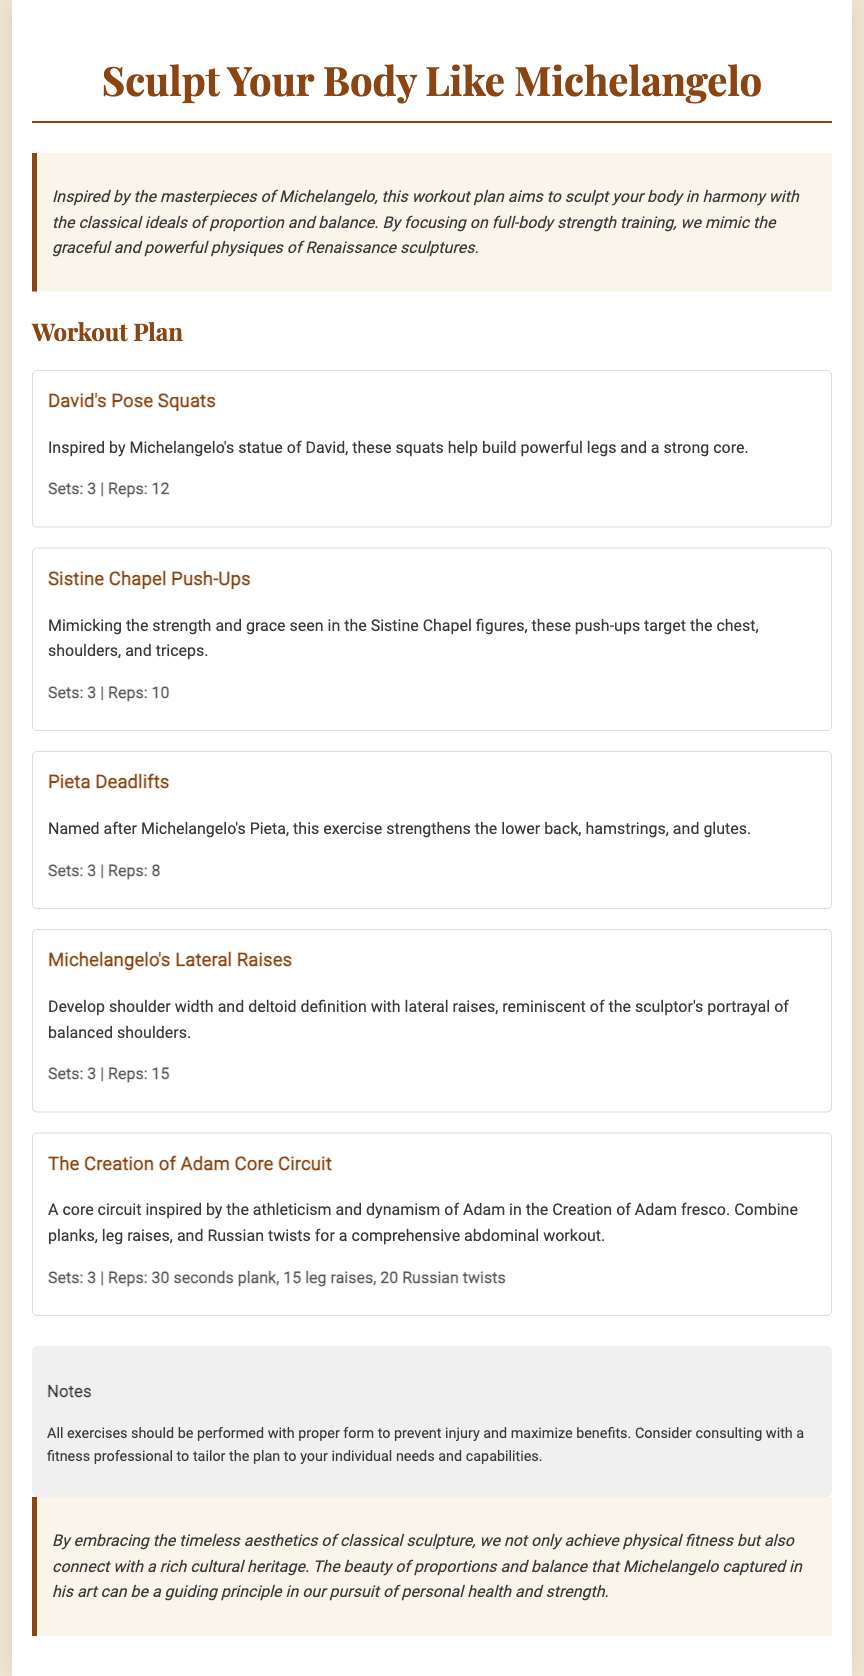What is the title of the workout plan? The title of the workout plan is prominently displayed at the top of the document.
Answer: Sculpt Your Body Like Michelangelo How many exercises are included in the workout plan? The workout plan lists five distinct exercises designed for strength training.
Answer: 5 What is the recommended number of sets for David's Pose Squats? The number of sets for David's Pose Squats is specified in the exercise details section.
Answer: 3 Which exercise targets the chest, shoulders, and triceps? The exercise targeting the chest, shoulders, and triceps is noted under its specific description.
Answer: Sistine Chapel Push-Ups What core circuit exercises are included in The Creation of Adam workout? The specific exercises included in the core circuit are mentioned in the description, focusing on various abdominal workouts.
Answer: Planks, leg raises, Russian twists What are the total repetitions for Pieta Deadlifts? The total repetitions prescribed for Pieta Deadlifts is stated clearly in the exercise details.
Answer: 8 What color is used for the main text in the document? The main text color is described in the style section of the code.
Answer: #3a3a3a What should one consider before starting the exercises? The notes section emphasizes the importance of form and seeking professional advice before beginning the workout.
Answer: Proper form and consulting a professional 